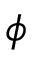Convert formula to latex. <formula><loc_0><loc_0><loc_500><loc_500>\phi</formula> 